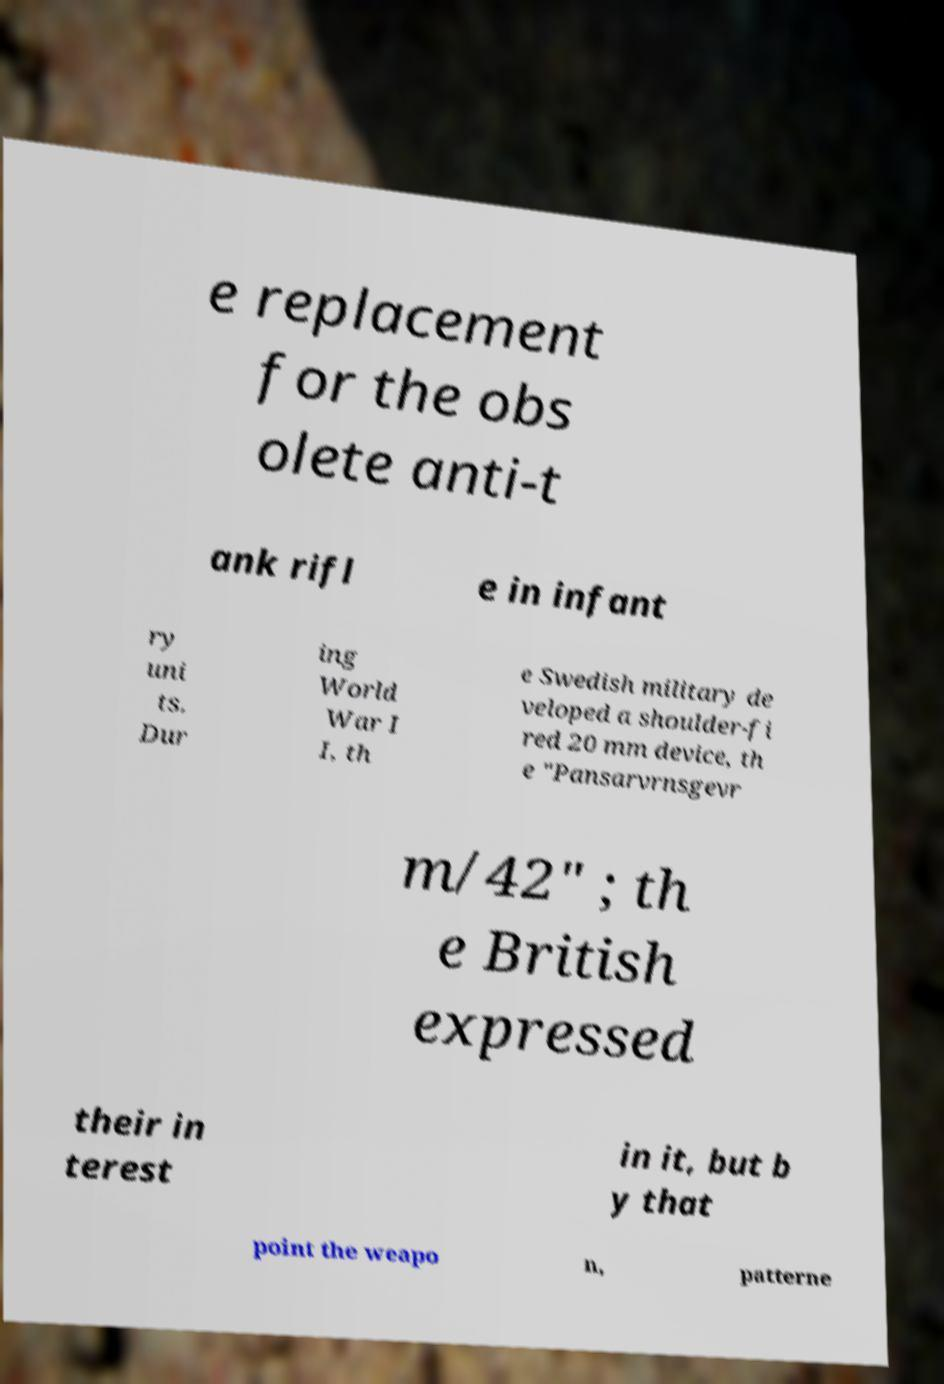There's text embedded in this image that I need extracted. Can you transcribe it verbatim? e replacement for the obs olete anti-t ank rifl e in infant ry uni ts. Dur ing World War I I, th e Swedish military de veloped a shoulder-fi red 20 mm device, th e "Pansarvrnsgevr m/42" ; th e British expressed their in terest in it, but b y that point the weapo n, patterne 